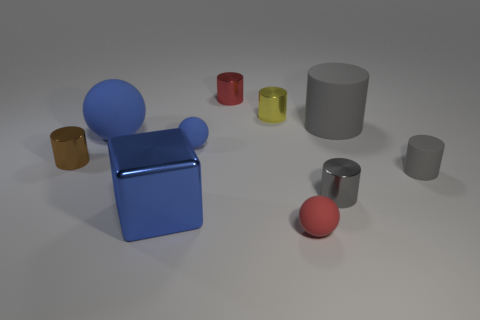Does the blue thing in front of the brown cylinder have the same size as the small rubber cylinder?
Give a very brief answer. No. There is a big object to the right of the large cube; what is it made of?
Your answer should be very brief. Rubber. Is the number of large gray rubber objects that are to the left of the large blue sphere the same as the number of gray rubber things that are behind the gray metallic object?
Give a very brief answer. No. What is the color of the other big thing that is the same shape as the brown object?
Provide a succinct answer. Gray. Are there any other things that are the same color as the small matte cylinder?
Offer a terse response. Yes. What number of rubber objects are either tiny gray objects or gray cylinders?
Provide a succinct answer. 2. Does the cube have the same color as the large sphere?
Ensure brevity in your answer.  Yes. Are there more tiny red metal things left of the yellow metal thing than yellow matte objects?
Make the answer very short. Yes. How many other things are there of the same material as the big blue ball?
Provide a short and direct response. 4. How many big things are gray metallic blocks or matte cylinders?
Your answer should be very brief. 1. 